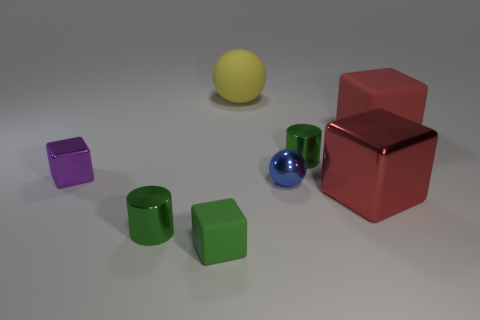There is another small thing that is the same shape as the purple shiny thing; what color is it?
Provide a short and direct response. Green. Is there any other thing that has the same shape as the purple thing?
Make the answer very short. Yes. There is a large red shiny thing; is its shape the same as the green metal object left of the tiny matte block?
Provide a short and direct response. No. What number of other things are there of the same material as the purple object
Offer a terse response. 4. Do the big matte block and the big block in front of the small sphere have the same color?
Offer a terse response. Yes. There is a small green cylinder on the right side of the large yellow object; what is its material?
Provide a short and direct response. Metal. Are there any large objects that have the same color as the large rubber cube?
Provide a short and direct response. Yes. There is a sphere that is the same size as the purple cube; what is its color?
Provide a short and direct response. Blue. What number of big objects are purple blocks or yellow rubber cylinders?
Ensure brevity in your answer.  0. Is the number of green shiny cylinders right of the small blue shiny ball the same as the number of tiny purple shiny cubes in front of the green rubber thing?
Make the answer very short. No. 